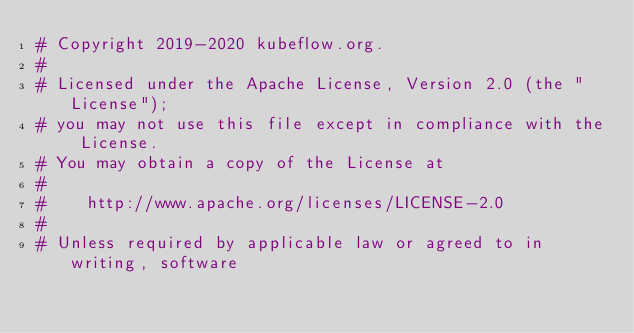<code> <loc_0><loc_0><loc_500><loc_500><_Python_># Copyright 2019-2020 kubeflow.org.
#
# Licensed under the Apache License, Version 2.0 (the "License");
# you may not use this file except in compliance with the License.
# You may obtain a copy of the License at
#
#    http://www.apache.org/licenses/LICENSE-2.0
#
# Unless required by applicable law or agreed to in writing, software</code> 